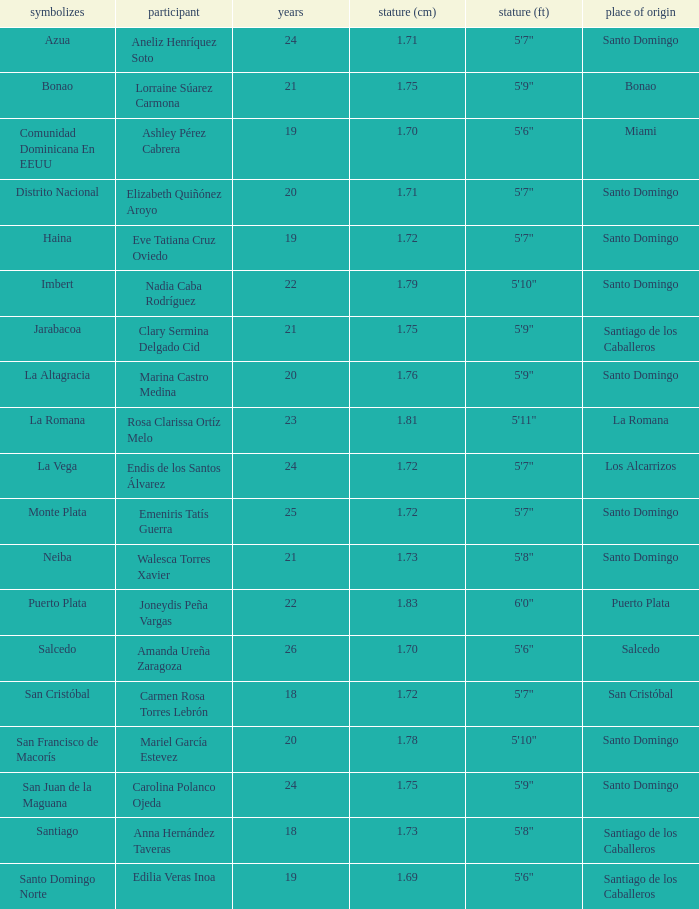Name the most age 26.0. Can you parse all the data within this table? {'header': ['symbolizes', 'participant', 'years', 'stature (cm)', 'stature (ft)', 'place of origin'], 'rows': [['Azua', 'Aneliz Henríquez Soto', '24', '1.71', '5\'7"', 'Santo Domingo'], ['Bonao', 'Lorraine Súarez Carmona', '21', '1.75', '5\'9"', 'Bonao'], ['Comunidad Dominicana En EEUU', 'Ashley Pérez Cabrera', '19', '1.70', '5\'6"', 'Miami'], ['Distrito Nacional', 'Elizabeth Quiñónez Aroyo', '20', '1.71', '5\'7"', 'Santo Domingo'], ['Haina', 'Eve Tatiana Cruz Oviedo', '19', '1.72', '5\'7"', 'Santo Domingo'], ['Imbert', 'Nadia Caba Rodríguez', '22', '1.79', '5\'10"', 'Santo Domingo'], ['Jarabacoa', 'Clary Sermina Delgado Cid', '21', '1.75', '5\'9"', 'Santiago de los Caballeros'], ['La Altagracia', 'Marina Castro Medina', '20', '1.76', '5\'9"', 'Santo Domingo'], ['La Romana', 'Rosa Clarissa Ortíz Melo', '23', '1.81', '5\'11"', 'La Romana'], ['La Vega', 'Endis de los Santos Álvarez', '24', '1.72', '5\'7"', 'Los Alcarrizos'], ['Monte Plata', 'Emeniris Tatís Guerra', '25', '1.72', '5\'7"', 'Santo Domingo'], ['Neiba', 'Walesca Torres Xavier', '21', '1.73', '5\'8"', 'Santo Domingo'], ['Puerto Plata', 'Joneydis Peña Vargas', '22', '1.83', '6\'0"', 'Puerto Plata'], ['Salcedo', 'Amanda Ureña Zaragoza', '26', '1.70', '5\'6"', 'Salcedo'], ['San Cristóbal', 'Carmen Rosa Torres Lebrón', '18', '1.72', '5\'7"', 'San Cristóbal'], ['San Francisco de Macorís', 'Mariel García Estevez', '20', '1.78', '5\'10"', 'Santo Domingo'], ['San Juan de la Maguana', 'Carolina Polanco Ojeda', '24', '1.75', '5\'9"', 'Santo Domingo'], ['Santiago', 'Anna Hernández Taveras', '18', '1.73', '5\'8"', 'Santiago de los Caballeros'], ['Santo Domingo Norte', 'Edilia Veras Inoa', '19', '1.69', '5\'6"', 'Santiago de los Caballeros']]} 